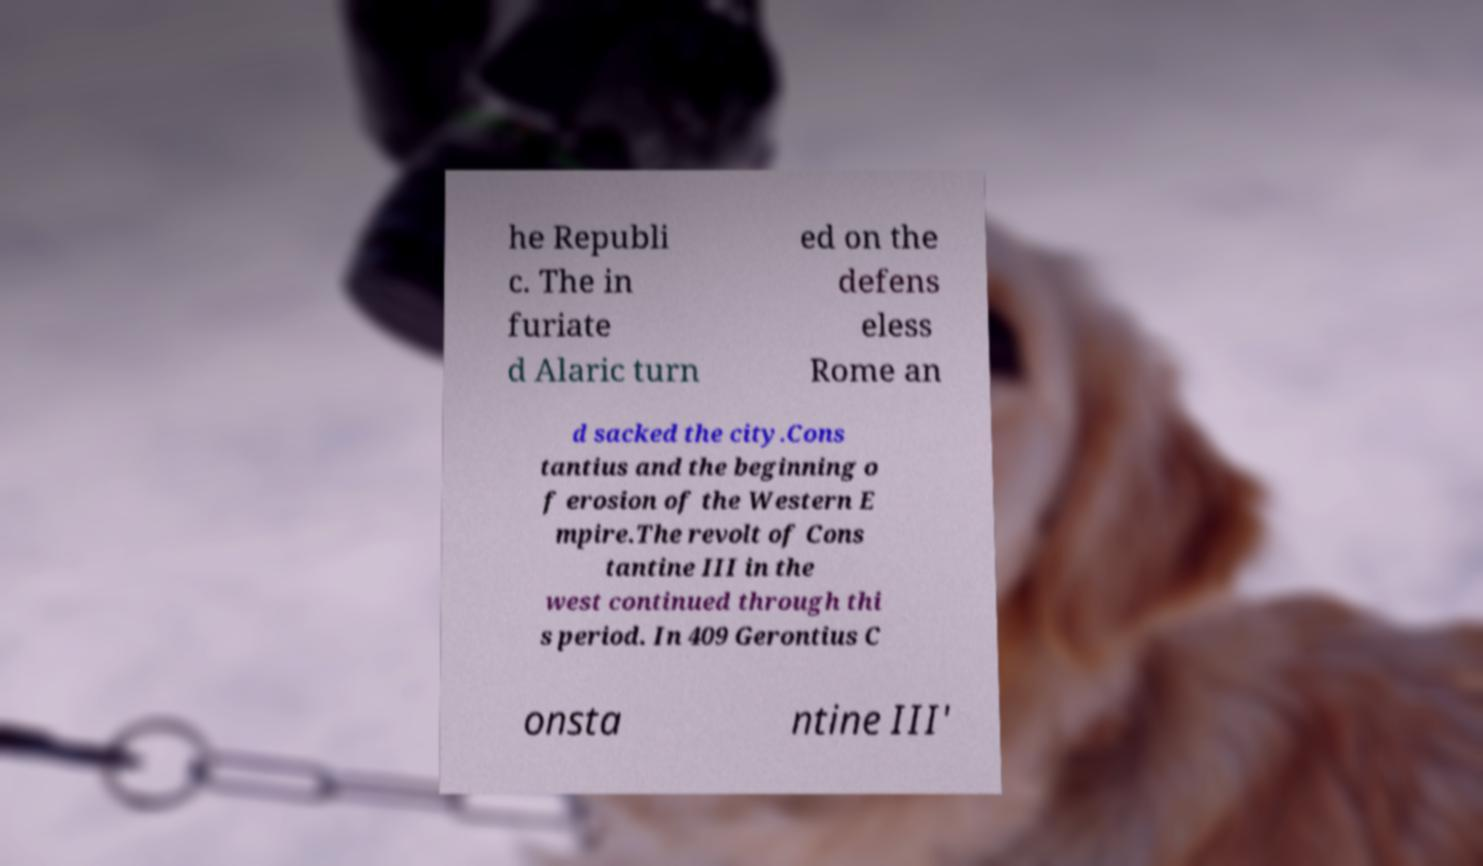What messages or text are displayed in this image? I need them in a readable, typed format. he Republi c. The in furiate d Alaric turn ed on the defens eless Rome an d sacked the city.Cons tantius and the beginning o f erosion of the Western E mpire.The revolt of Cons tantine III in the west continued through thi s period. In 409 Gerontius C onsta ntine III' 